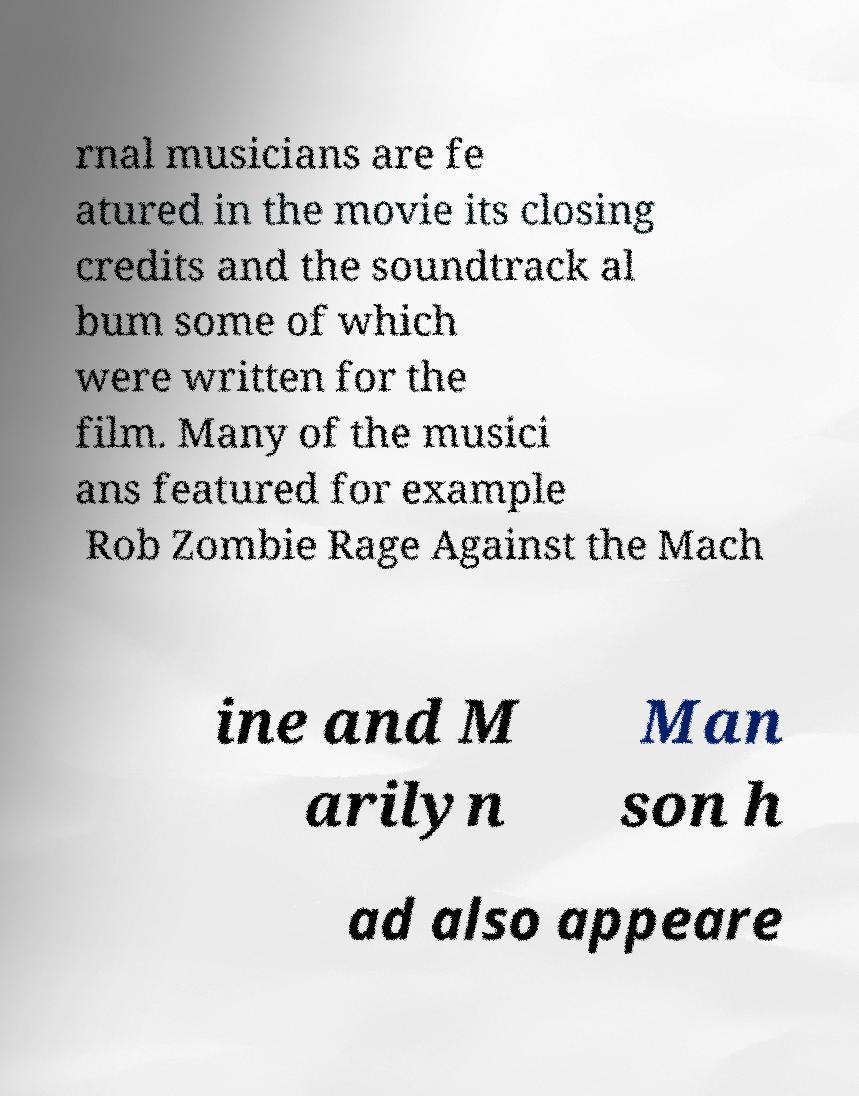What messages or text are displayed in this image? I need them in a readable, typed format. rnal musicians are fe atured in the movie its closing credits and the soundtrack al bum some of which were written for the film. Many of the musici ans featured for example Rob Zombie Rage Against the Mach ine and M arilyn Man son h ad also appeare 